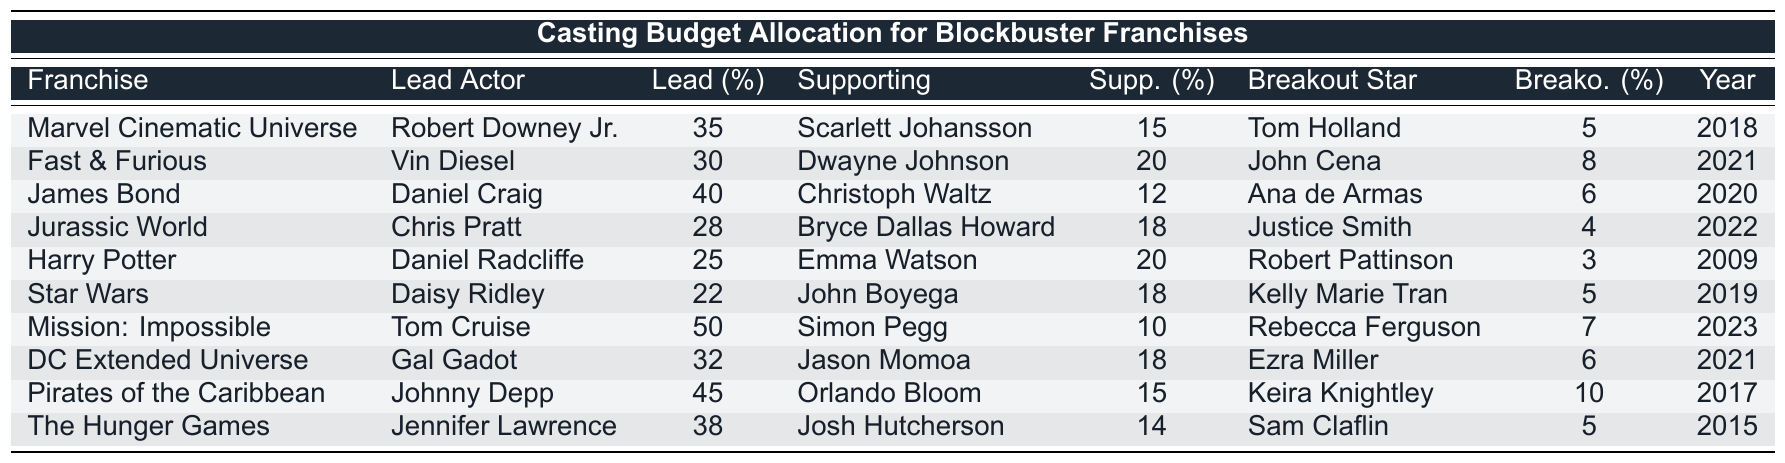What's the highest budget percentage allocated for a lead actor in the table? Looking through the table, the maximum percentage allocated for a lead actor is associated with Tom Cruise in "Mission: Impossible," which is 50%.
Answer: 50% Which franchise has the lowest budget percentage for a breakout star? By examining the breakout star budget percentages in the table, the lowest is associated with Justice Smith in "Jurassic World," which is 4%.
Answer: 4% What is the total budget percentage allocated for supporting actors across all franchises? To find the total for supporting actors, we add the supporting actor budget percentages: 15 + 20 + 12 + 18 + 20 + 18 + 10 + 18 + 15 + 14 =  180%.
Answer: 180% Is the budget allocation for the lead actor in "Harry Potter" greater than that in "Star Wars"? Comparing the lead actor budgets, "Harry Potter" has 25% while "Star Wars" has 22%. Since 25% is greater than 22%, the statement is true.
Answer: Yes What is the difference in budget percentage allocated for lead actors between the "Pirates of the Caribbean" and "Fast & Furious"? The lead actor budget for "Pirates of the Caribbean" is 45%, and for "Fast & Furious" is 30%. The difference is 45 - 30 = 15%.
Answer: 15% Which year had the highest lead actor budget percentage, and what was it? Looking at the years and their corresponding lead actor budgets, 2023 ("Mission: Impossible" with 50%) is the highest.
Answer: 2023, 50% If we look at the supporting actor budgets, which franchise has the largest allocation, and what is that percentage? The largest supporting actor budget percentage is from "Fast & Furious" with 20%, which can be found by observing the corresponding value in that franchise's row.
Answer: Fast & Furious, 20% Which franchise has the highest combined budget percentage for its lead actor and supporting actor? By calculating the sum of lead and supporting actor budgets for each franchise: For example, "Mission: Impossible" has 50 + 10 = 60%. The highest is from "Pirates of the Caribbean" with 45 + 15 = 60%. Thus, both franchises tie, but we'll take "Pirates of the Caribbean" for the first instance of this value.
Answer: Pirates of the Caribbean, 60% How does the supporting actor budget for Daniel Craig in "James Bond" compare to that for Vin Diesel in "Fast & Furious"? Daniel Craig's supporting actor budget is 12% while Vin Diesel's is 20%. Since 12% is less than 20%, Vin Diesel has a higher budget.
Answer: Vin Diesel has a higher budget What percentage of the total actor budget does the lead actor typically occupy across all franchises? By summing up all lead actor budgets: 35 + 30 + 40 + 28 + 25 + 22 + 50 + 32 + 45 + 38 =  345%. Since there are 10 data points, 345 / 10 = 34.5%.
Answer: 34.5% 